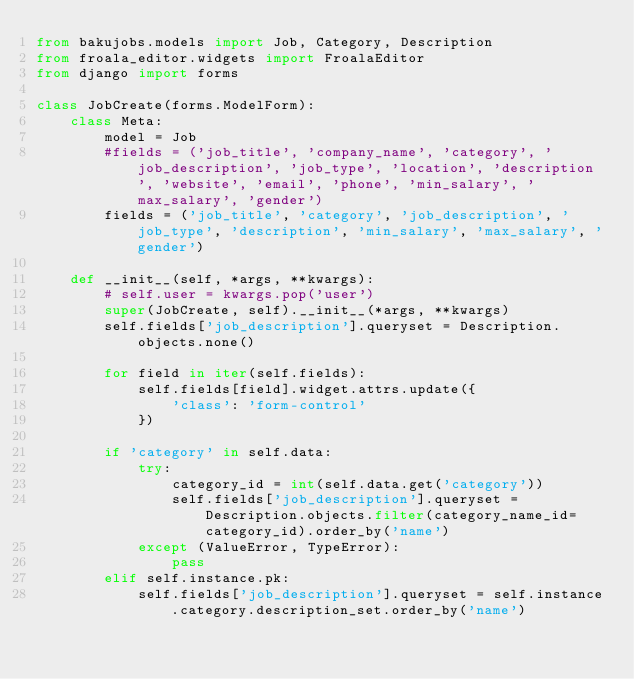Convert code to text. <code><loc_0><loc_0><loc_500><loc_500><_Python_>from bakujobs.models import Job, Category, Description
from froala_editor.widgets import FroalaEditor
from django import forms

class JobCreate(forms.ModelForm):
    class Meta:
        model = Job
        #fields = ('job_title', 'company_name', 'category', 'job_description', 'job_type', 'location', 'description', 'website', 'email', 'phone', 'min_salary', 'max_salary', 'gender')
        fields = ('job_title', 'category', 'job_description', 'job_type', 'description', 'min_salary', 'max_salary', 'gender')

    def __init__(self, *args, **kwargs):
        # self.user = kwargs.pop('user')
        super(JobCreate, self).__init__(*args, **kwargs)
        self.fields['job_description'].queryset = Description.objects.none()

        for field in iter(self.fields):
            self.fields[field].widget.attrs.update({
                'class': 'form-control'
            })

        if 'category' in self.data:
            try:
                category_id = int(self.data.get('category'))
                self.fields['job_description'].queryset = Description.objects.filter(category_name_id=category_id).order_by('name')
            except (ValueError, TypeError):
                pass
        elif self.instance.pk:
            self.fields['job_description'].queryset = self.instance.category.description_set.order_by('name')
</code> 